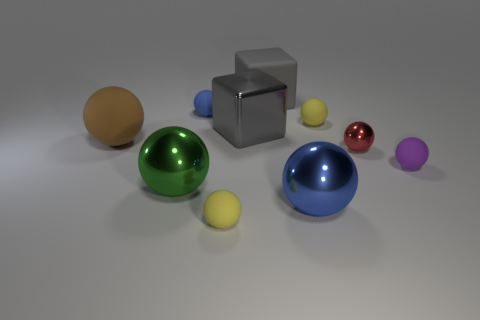How many objects are objects behind the brown ball or rubber spheres in front of the red sphere?
Provide a succinct answer. 6. Are there fewer large rubber things behind the blue rubber object than tiny brown metal cubes?
Keep it short and to the point. No. Is the material of the big blue ball the same as the small yellow object left of the big gray rubber cube?
Give a very brief answer. No. What material is the red ball?
Offer a terse response. Metal. What is the brown object behind the large ball to the right of the yellow thing on the left side of the gray matte block made of?
Keep it short and to the point. Rubber. Does the metal cube have the same color as the ball that is in front of the big blue ball?
Your answer should be very brief. No. Is there anything else that has the same shape as the brown rubber thing?
Give a very brief answer. Yes. What color is the large thing that is behind the gray object left of the large rubber block?
Your answer should be compact. Gray. How many purple rubber spheres are there?
Offer a terse response. 1. What number of metal things are either large blue objects or red spheres?
Provide a succinct answer. 2. 